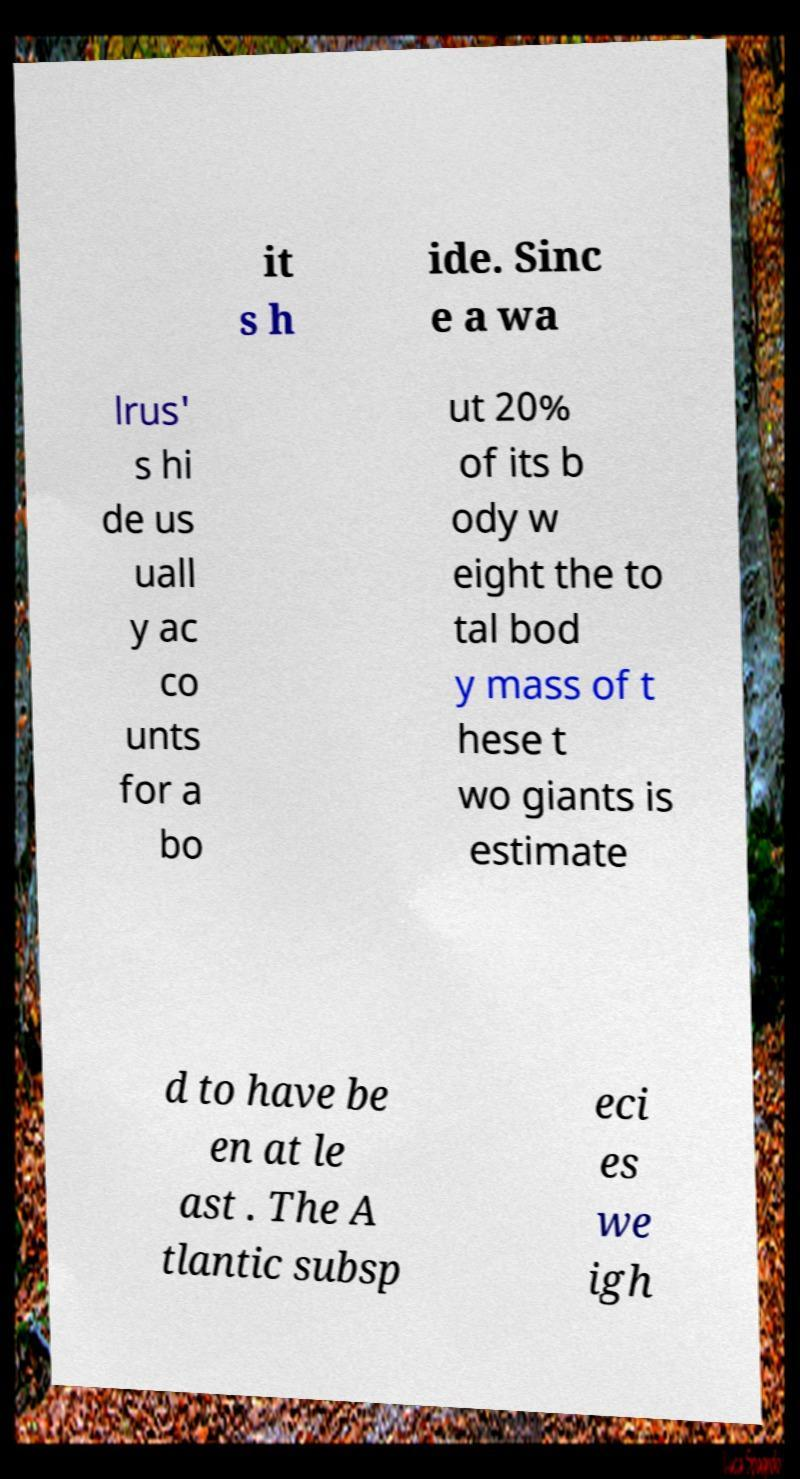What messages or text are displayed in this image? I need them in a readable, typed format. it s h ide. Sinc e a wa lrus' s hi de us uall y ac co unts for a bo ut 20% of its b ody w eight the to tal bod y mass of t hese t wo giants is estimate d to have be en at le ast . The A tlantic subsp eci es we igh 